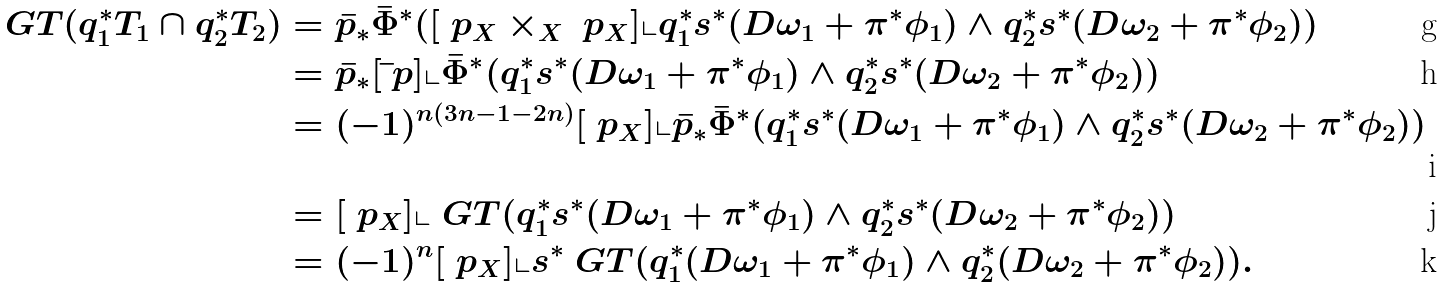<formula> <loc_0><loc_0><loc_500><loc_500>\ G T ( q _ { 1 } ^ { * } T _ { 1 } \cap q _ { 2 } ^ { * } T _ { 2 } ) & = \bar { p } _ { * } \bar { \Phi } ^ { * } ( [ \ p _ { X } \times _ { X } \ p _ { X } ] \llcorner q _ { 1 } ^ { * } s ^ { * } ( D \omega _ { 1 } + \pi ^ { * } \phi _ { 1 } ) \wedge q _ { 2 } ^ { * } s ^ { * } ( D \omega _ { 2 } + \pi ^ { * } \phi _ { 2 } ) ) \\ & = \bar { p } _ { * } [ \bar { \ } p ] \llcorner \bar { \Phi } ^ { * } ( q _ { 1 } ^ { * } s ^ { * } ( D \omega _ { 1 } + \pi ^ { * } \phi _ { 1 } ) \wedge q _ { 2 } ^ { * } s ^ { * } ( D \omega _ { 2 } + \pi ^ { * } \phi _ { 2 } ) ) \\ & = ( - 1 ) ^ { n ( 3 n - 1 - 2 n ) } [ \ p _ { X } ] \llcorner \bar { p } _ { * } \bar { \Phi } ^ { * } ( q _ { 1 } ^ { * } s ^ { * } ( D \omega _ { 1 } + \pi ^ { * } \phi _ { 1 } ) \wedge q _ { 2 } ^ { * } s ^ { * } ( D \omega _ { 2 } + \pi ^ { * } \phi _ { 2 } ) ) \\ & = [ \ p _ { X } ] \llcorner \ G T ( q _ { 1 } ^ { * } s ^ { * } ( D \omega _ { 1 } + \pi ^ { * } \phi _ { 1 } ) \wedge q _ { 2 } ^ { * } s ^ { * } ( D \omega _ { 2 } + \pi ^ { * } \phi _ { 2 } ) ) \\ & = ( - 1 ) ^ { n } [ \ p _ { X } ] \llcorner s ^ { * } \ G T ( q _ { 1 } ^ { * } ( D \omega _ { 1 } + \pi ^ { * } \phi _ { 1 } ) \wedge q _ { 2 } ^ { * } ( D \omega _ { 2 } + \pi ^ { * } \phi _ { 2 } ) ) .</formula> 